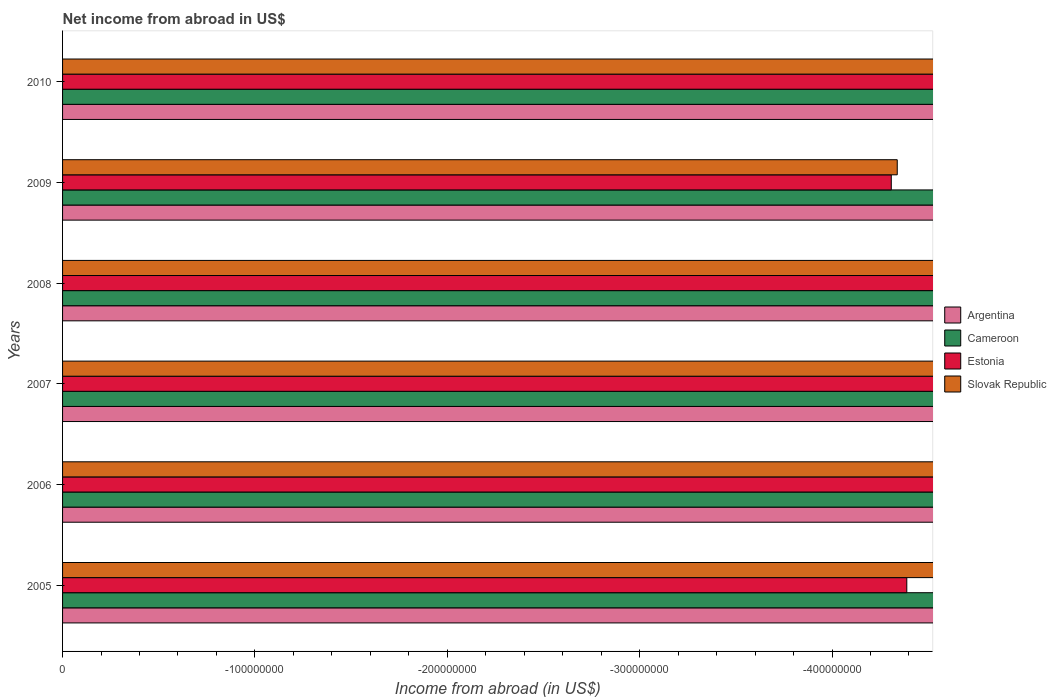How many bars are there on the 4th tick from the top?
Give a very brief answer. 0. Across all years, what is the minimum net income from abroad in Cameroon?
Provide a succinct answer. 0. What is the total net income from abroad in Estonia in the graph?
Give a very brief answer. 0. What is the difference between the net income from abroad in Estonia in 2005 and the net income from abroad in Argentina in 2009?
Make the answer very short. 0. What is the average net income from abroad in Cameroon per year?
Your answer should be very brief. 0. Is it the case that in every year, the sum of the net income from abroad in Cameroon and net income from abroad in Estonia is greater than the sum of net income from abroad in Argentina and net income from abroad in Slovak Republic?
Offer a terse response. No. How many bars are there?
Your response must be concise. 0. How many years are there in the graph?
Your answer should be compact. 6. Does the graph contain any zero values?
Your answer should be very brief. Yes. Does the graph contain grids?
Provide a succinct answer. No. How many legend labels are there?
Ensure brevity in your answer.  4. How are the legend labels stacked?
Your response must be concise. Vertical. What is the title of the graph?
Offer a terse response. Net income from abroad in US$. Does "Guam" appear as one of the legend labels in the graph?
Make the answer very short. No. What is the label or title of the X-axis?
Provide a short and direct response. Income from abroad (in US$). What is the Income from abroad (in US$) in Argentina in 2005?
Provide a succinct answer. 0. What is the Income from abroad (in US$) of Cameroon in 2005?
Offer a very short reply. 0. What is the Income from abroad (in US$) in Estonia in 2005?
Keep it short and to the point. 0. What is the Income from abroad (in US$) in Slovak Republic in 2005?
Offer a terse response. 0. What is the Income from abroad (in US$) of Argentina in 2006?
Provide a short and direct response. 0. What is the Income from abroad (in US$) of Estonia in 2006?
Your answer should be compact. 0. What is the Income from abroad (in US$) of Slovak Republic in 2006?
Make the answer very short. 0. What is the Income from abroad (in US$) in Argentina in 2007?
Your answer should be very brief. 0. What is the Income from abroad (in US$) of Cameroon in 2007?
Your response must be concise. 0. What is the Income from abroad (in US$) in Slovak Republic in 2007?
Provide a succinct answer. 0. What is the Income from abroad (in US$) of Cameroon in 2008?
Your response must be concise. 0. What is the Income from abroad (in US$) of Estonia in 2008?
Provide a short and direct response. 0. What is the Income from abroad (in US$) of Argentina in 2009?
Ensure brevity in your answer.  0. What is the Income from abroad (in US$) of Cameroon in 2009?
Offer a terse response. 0. What is the Income from abroad (in US$) of Estonia in 2009?
Your answer should be very brief. 0. What is the Income from abroad (in US$) in Estonia in 2010?
Your answer should be very brief. 0. What is the total Income from abroad (in US$) in Argentina in the graph?
Ensure brevity in your answer.  0. What is the total Income from abroad (in US$) of Cameroon in the graph?
Ensure brevity in your answer.  0. What is the average Income from abroad (in US$) in Estonia per year?
Keep it short and to the point. 0. What is the average Income from abroad (in US$) in Slovak Republic per year?
Make the answer very short. 0. 